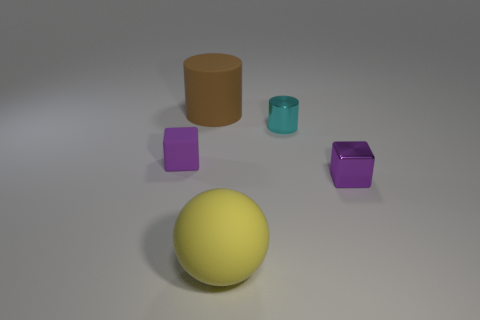Add 5 tiny metallic cubes. How many objects exist? 10 Subtract all spheres. How many objects are left? 4 Add 5 yellow objects. How many yellow objects exist? 6 Subtract 0 green cylinders. How many objects are left? 5 Subtract all large yellow matte things. Subtract all tiny purple cubes. How many objects are left? 2 Add 5 cyan objects. How many cyan objects are left? 6 